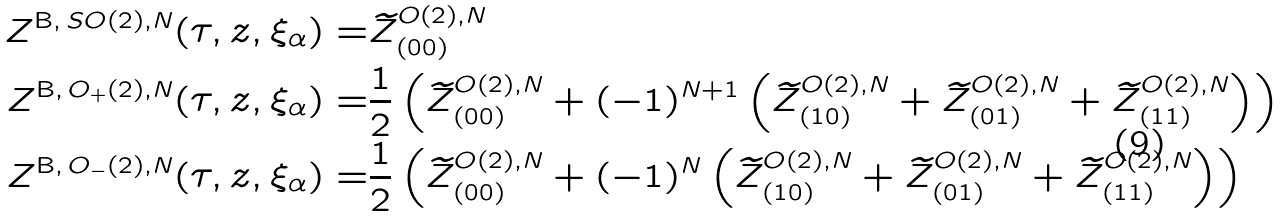<formula> <loc_0><loc_0><loc_500><loc_500>Z ^ { \text {B} , \, S O ( 2 ) , N } ( \tau , z , \xi _ { \alpha } ) = & \widetilde { Z } ^ { O ( 2 ) , N } _ { ( 0 0 ) } \\ Z ^ { \text {B} , \, O _ { + } ( 2 ) , N } ( \tau , z , \xi _ { \alpha } ) = & \frac { 1 } { 2 } \left ( \widetilde { Z } ^ { O ( 2 ) , N } _ { ( 0 0 ) } + ( - 1 ) ^ { N + 1 } \left ( \widetilde { Z } ^ { O ( 2 ) , N } _ { ( 1 0 ) } + \widetilde { Z } ^ { O ( 2 ) , N } _ { ( 0 1 ) } + \widetilde { Z } ^ { O ( 2 ) , N } _ { ( 1 1 ) } \right ) \right ) \\ Z ^ { \text {B} , \, O _ { - } ( 2 ) , N } ( \tau , z , \xi _ { \alpha } ) = & \frac { 1 } { 2 } \left ( \widetilde { Z } ^ { O ( 2 ) , N } _ { ( 0 0 ) } + ( - 1 ) ^ { N } \left ( \widetilde { Z } ^ { O ( 2 ) , N } _ { ( 1 0 ) } + \widetilde { Z } ^ { O ( 2 ) , N } _ { ( 0 1 ) } + \widetilde { Z } ^ { O ( 2 ) , N } _ { ( 1 1 ) } \right ) \right )</formula> 